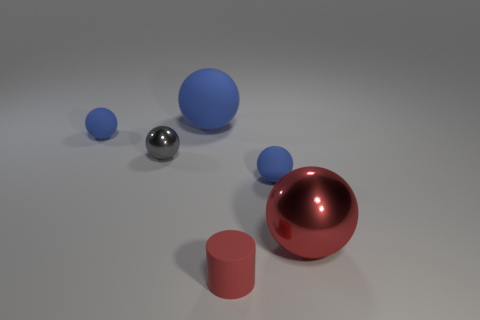Subtract all blue spheres. How many were subtracted if there are1blue spheres left? 2 Subtract all purple cubes. How many blue balls are left? 3 Subtract all gray spheres. How many spheres are left? 4 Subtract all gray shiny balls. How many balls are left? 4 Subtract 1 spheres. How many spheres are left? 4 Subtract all yellow spheres. Subtract all gray blocks. How many spheres are left? 5 Add 4 big blue shiny spheres. How many objects exist? 10 Subtract all cylinders. How many objects are left? 5 Subtract all red matte cylinders. Subtract all large blue rubber things. How many objects are left? 4 Add 5 gray spheres. How many gray spheres are left? 6 